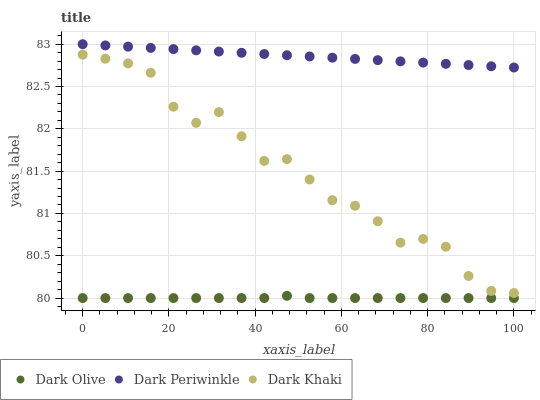Does Dark Olive have the minimum area under the curve?
Answer yes or no. Yes. Does Dark Periwinkle have the maximum area under the curve?
Answer yes or no. Yes. Does Dark Periwinkle have the minimum area under the curve?
Answer yes or no. No. Does Dark Olive have the maximum area under the curve?
Answer yes or no. No. Is Dark Periwinkle the smoothest?
Answer yes or no. Yes. Is Dark Khaki the roughest?
Answer yes or no. Yes. Is Dark Olive the smoothest?
Answer yes or no. No. Is Dark Olive the roughest?
Answer yes or no. No. Does Dark Olive have the lowest value?
Answer yes or no. Yes. Does Dark Periwinkle have the lowest value?
Answer yes or no. No. Does Dark Periwinkle have the highest value?
Answer yes or no. Yes. Does Dark Olive have the highest value?
Answer yes or no. No. Is Dark Olive less than Dark Khaki?
Answer yes or no. Yes. Is Dark Periwinkle greater than Dark Khaki?
Answer yes or no. Yes. Does Dark Olive intersect Dark Khaki?
Answer yes or no. No. 